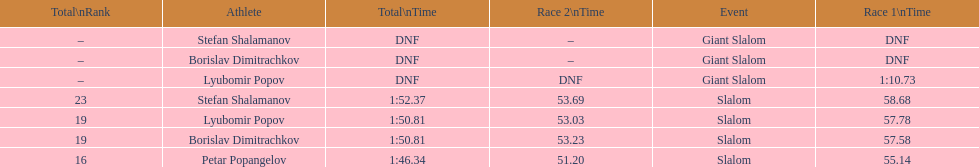How many athletes are there total? 4. 